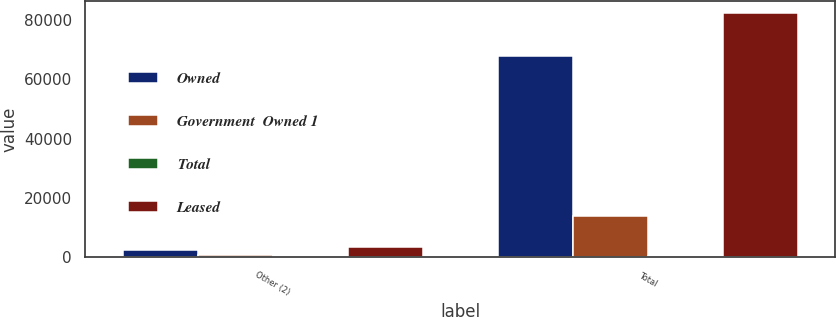Convert chart. <chart><loc_0><loc_0><loc_500><loc_500><stacked_bar_chart><ecel><fcel>Other (2)<fcel>Total<nl><fcel>Owned<fcel>2395<fcel>67830<nl><fcel>Government  Owned 1<fcel>876<fcel>14018<nl><fcel>Total<fcel>318<fcel>318<nl><fcel>Leased<fcel>3589<fcel>82166<nl></chart> 